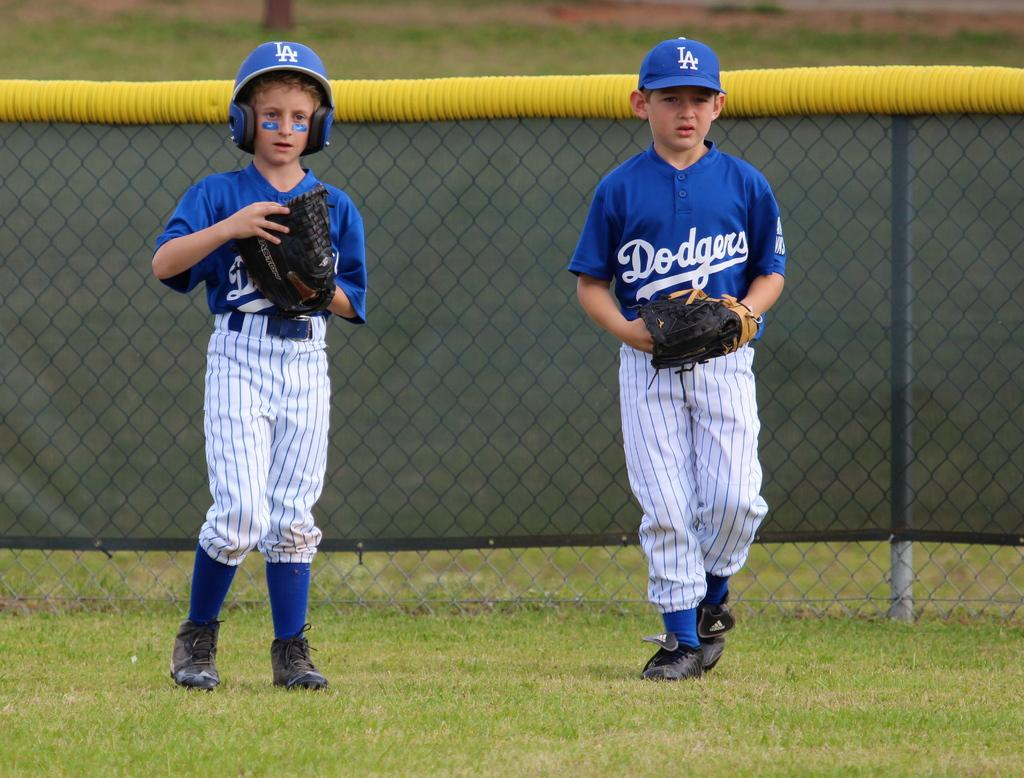Provide a one-sentence caption for the provided image. Two little league baseball players dressed in LA Dodgers uniforms. 